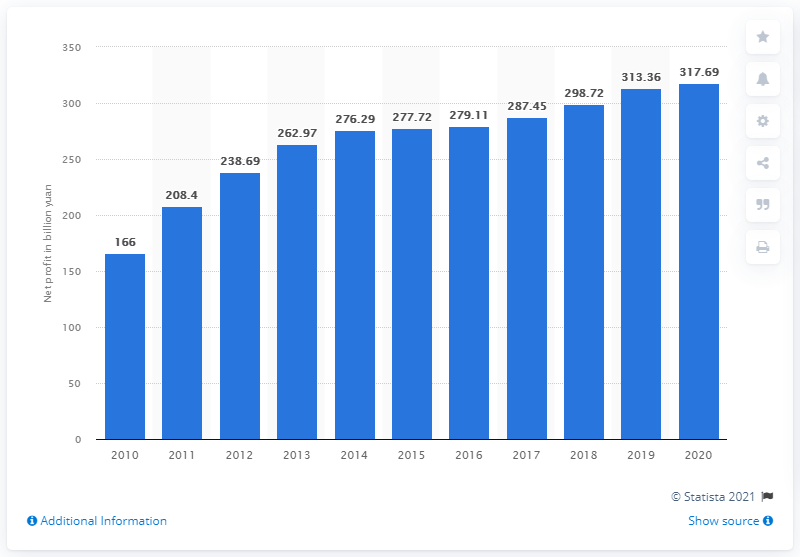Identify some key points in this picture. The net profit of the Industrial and Commercial Bank of China in 2020 was 317.69 million. 